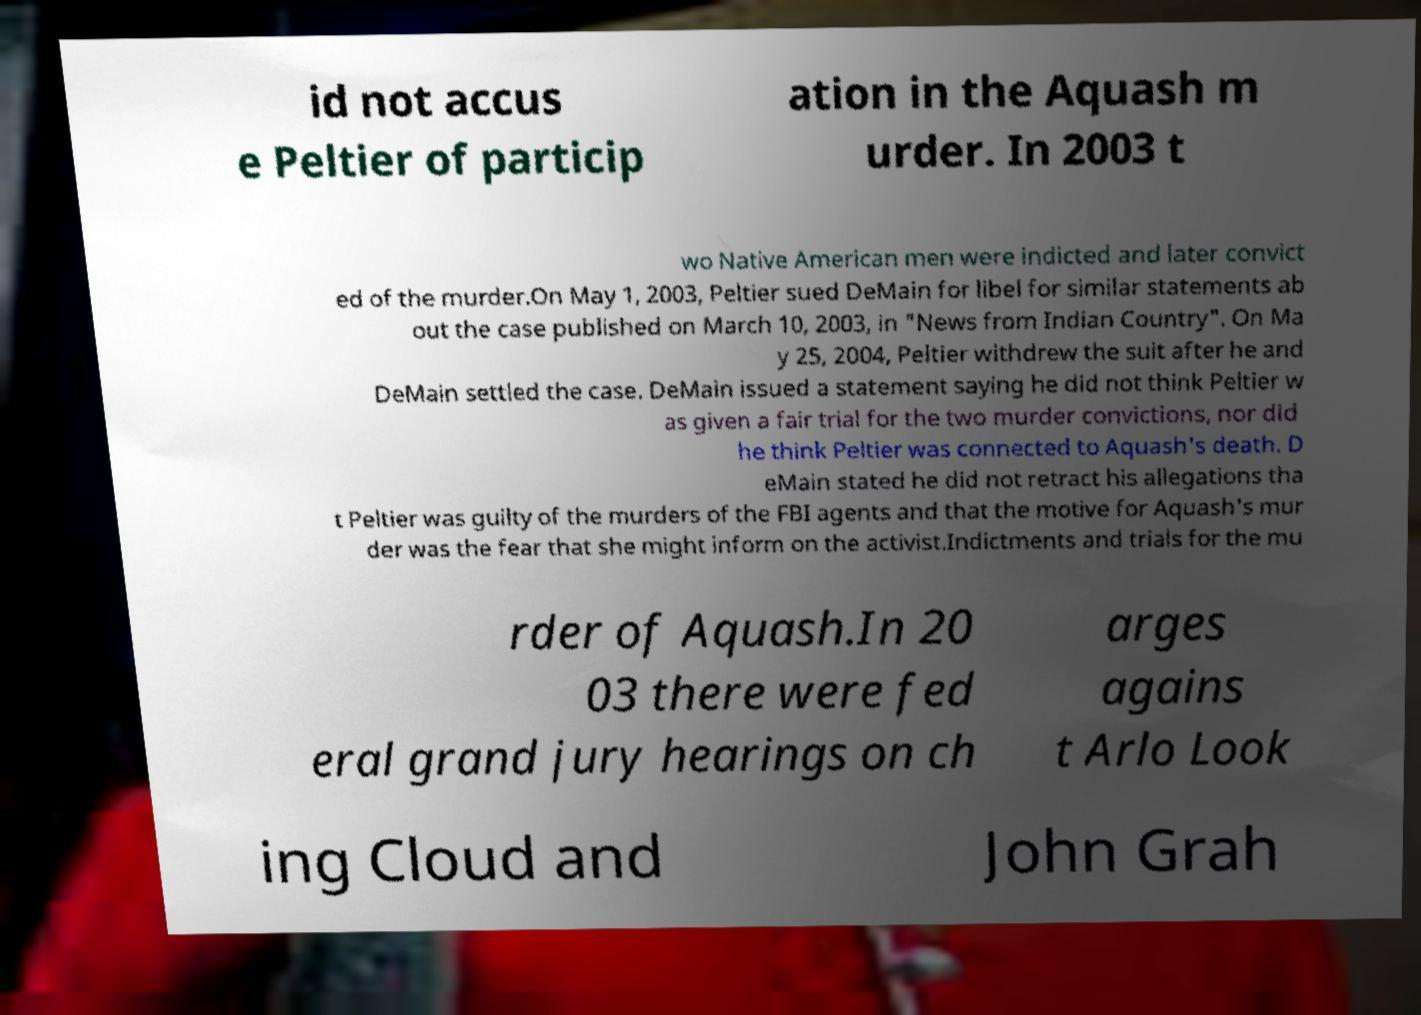Could you extract and type out the text from this image? id not accus e Peltier of particip ation in the Aquash m urder. In 2003 t wo Native American men were indicted and later convict ed of the murder.On May 1, 2003, Peltier sued DeMain for libel for similar statements ab out the case published on March 10, 2003, in "News from Indian Country". On Ma y 25, 2004, Peltier withdrew the suit after he and DeMain settled the case. DeMain issued a statement saying he did not think Peltier w as given a fair trial for the two murder convictions, nor did he think Peltier was connected to Aquash's death. D eMain stated he did not retract his allegations tha t Peltier was guilty of the murders of the FBI agents and that the motive for Aquash's mur der was the fear that she might inform on the activist.Indictments and trials for the mu rder of Aquash.In 20 03 there were fed eral grand jury hearings on ch arges agains t Arlo Look ing Cloud and John Grah 